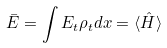Convert formula to latex. <formula><loc_0><loc_0><loc_500><loc_500>\bar { E } = \int E _ { t } \rho _ { t } d x = \langle \hat { H } \rangle</formula> 